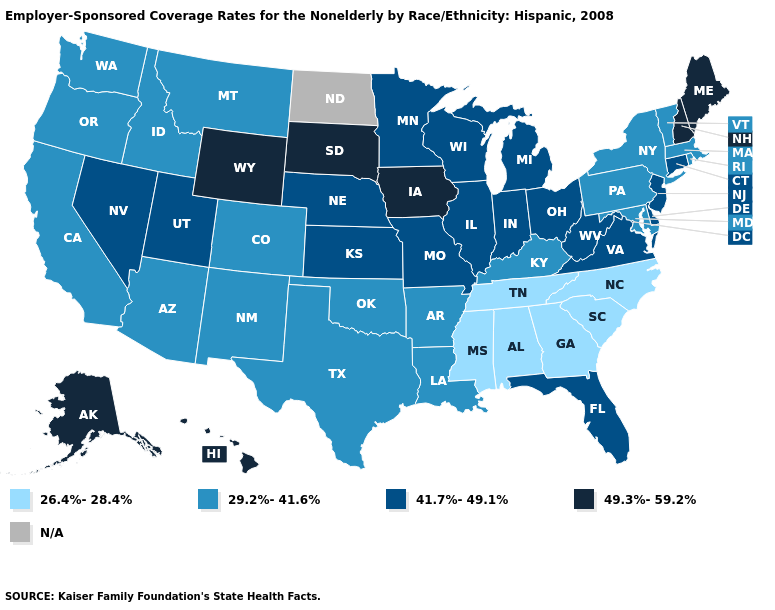Among the states that border New Mexico , does Utah have the lowest value?
Keep it brief. No. Name the states that have a value in the range N/A?
Be succinct. North Dakota. Name the states that have a value in the range 49.3%-59.2%?
Concise answer only. Alaska, Hawaii, Iowa, Maine, New Hampshire, South Dakota, Wyoming. Name the states that have a value in the range 49.3%-59.2%?
Be succinct. Alaska, Hawaii, Iowa, Maine, New Hampshire, South Dakota, Wyoming. Which states have the lowest value in the South?
Answer briefly. Alabama, Georgia, Mississippi, North Carolina, South Carolina, Tennessee. What is the value of Rhode Island?
Quick response, please. 29.2%-41.6%. What is the value of Vermont?
Short answer required. 29.2%-41.6%. Name the states that have a value in the range 29.2%-41.6%?
Concise answer only. Arizona, Arkansas, California, Colorado, Idaho, Kentucky, Louisiana, Maryland, Massachusetts, Montana, New Mexico, New York, Oklahoma, Oregon, Pennsylvania, Rhode Island, Texas, Vermont, Washington. Name the states that have a value in the range N/A?
Be succinct. North Dakota. Is the legend a continuous bar?
Concise answer only. No. What is the value of North Dakota?
Quick response, please. N/A. Does the first symbol in the legend represent the smallest category?
Write a very short answer. Yes. What is the value of Kentucky?
Concise answer only. 29.2%-41.6%. What is the lowest value in the USA?
Short answer required. 26.4%-28.4%. 